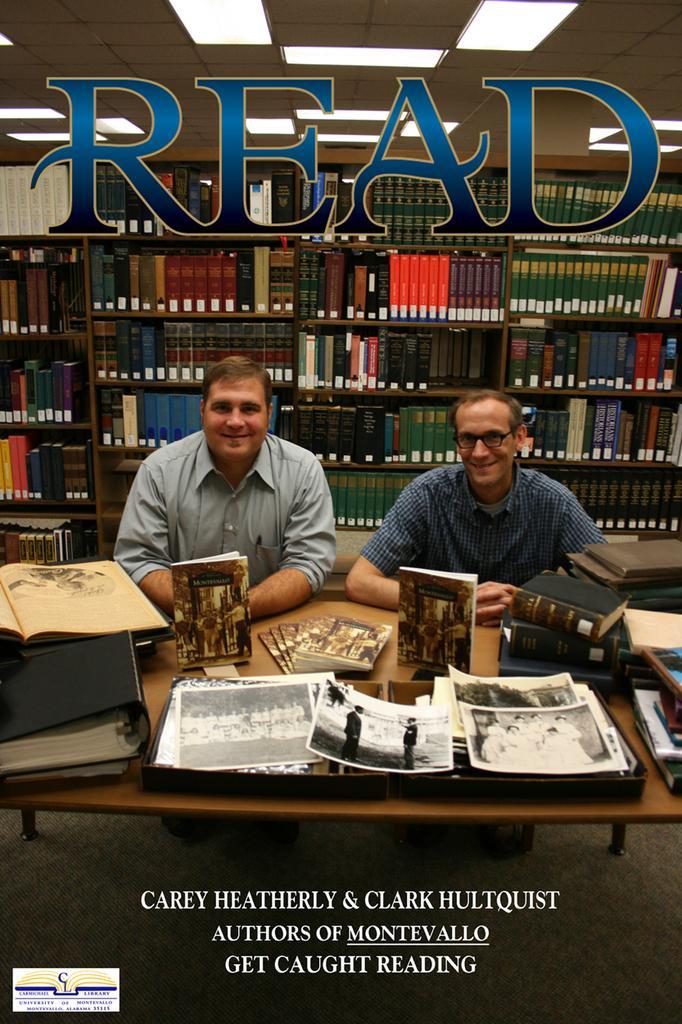Could you give a brief overview of what you see in this image? There are two persons sitting in chair and there is a table in front of them which has books and some pictures on it and there is a book shelf behind them, There is a read written on it. 